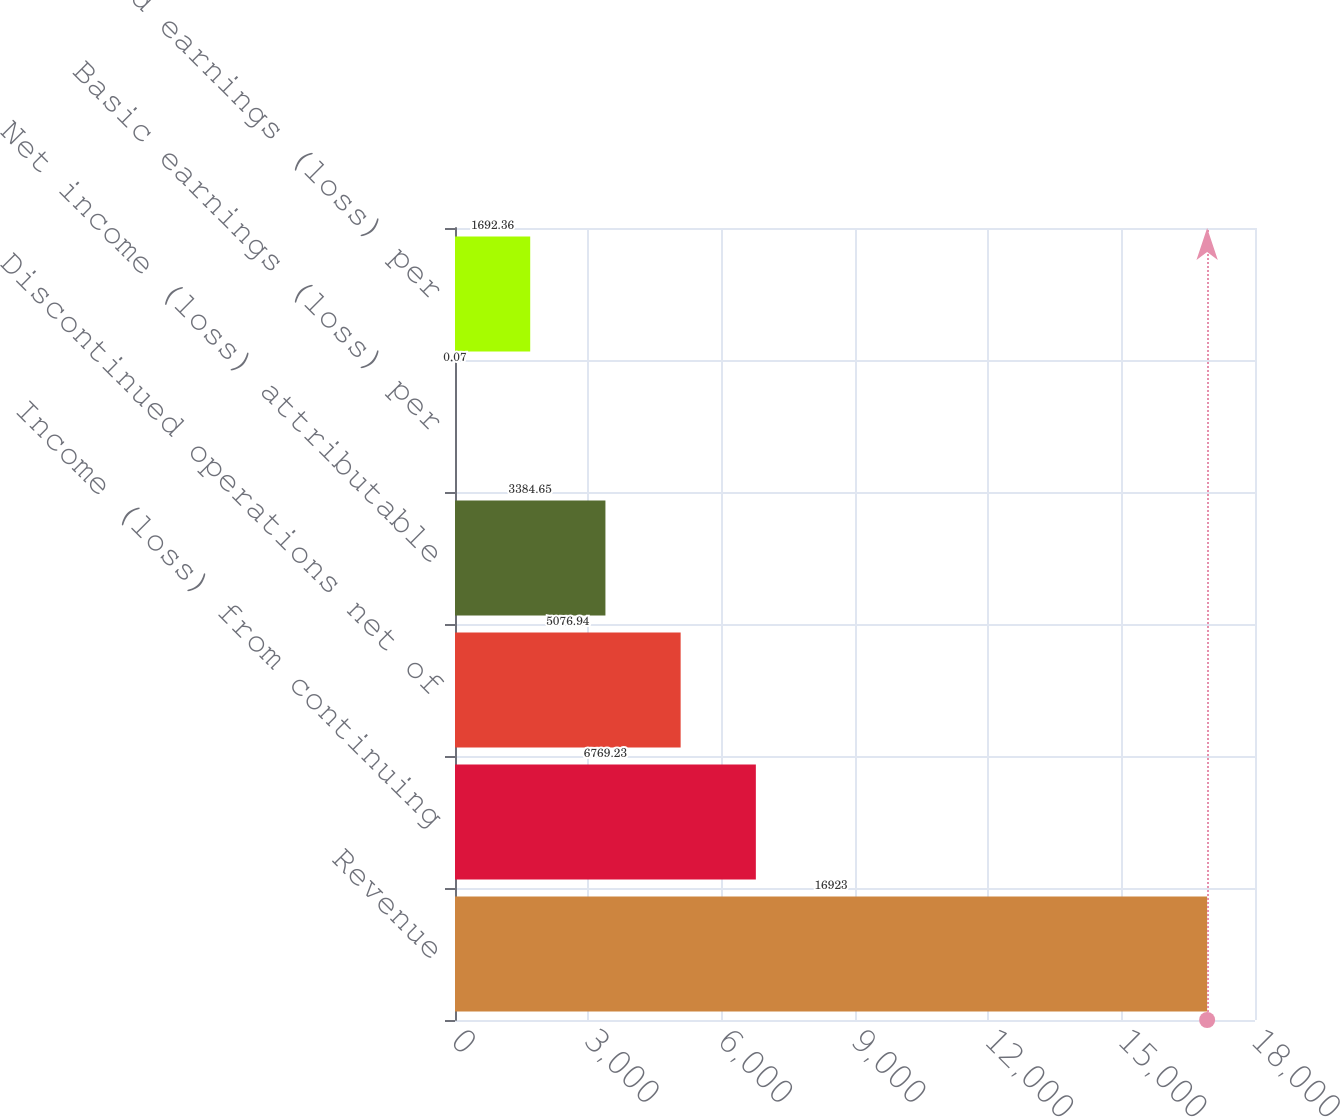<chart> <loc_0><loc_0><loc_500><loc_500><bar_chart><fcel>Revenue<fcel>Income (loss) from continuing<fcel>Discontinued operations net of<fcel>Net income (loss) attributable<fcel>Basic earnings (loss) per<fcel>Diluted earnings (loss) per<nl><fcel>16923<fcel>6769.23<fcel>5076.94<fcel>3384.65<fcel>0.07<fcel>1692.36<nl></chart> 